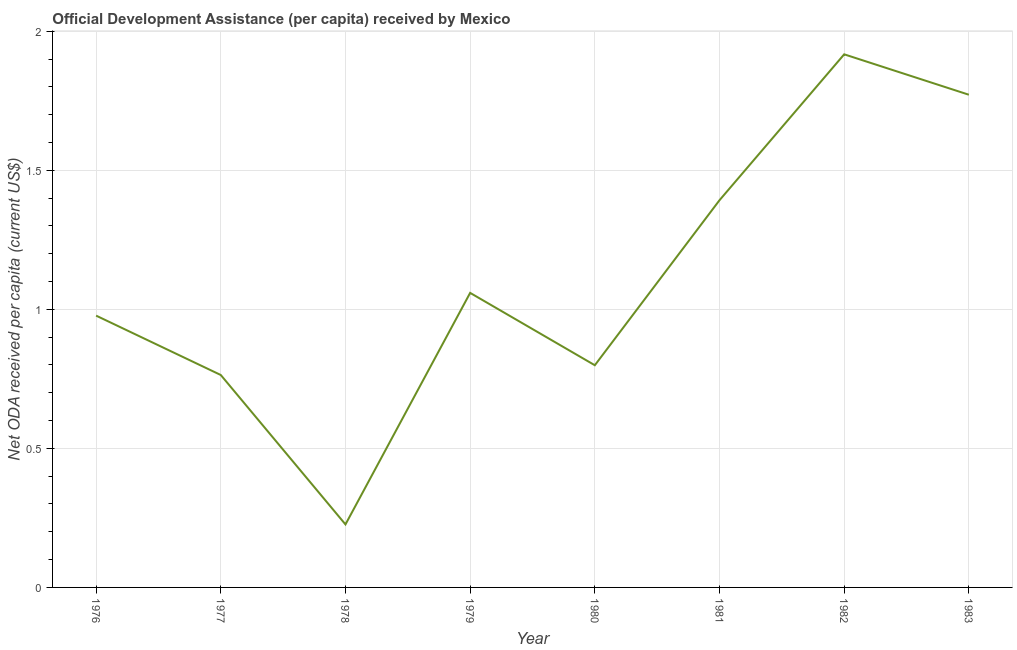What is the net oda received per capita in 1978?
Give a very brief answer. 0.23. Across all years, what is the maximum net oda received per capita?
Your response must be concise. 1.92. Across all years, what is the minimum net oda received per capita?
Your answer should be very brief. 0.23. In which year was the net oda received per capita minimum?
Offer a terse response. 1978. What is the sum of the net oda received per capita?
Provide a short and direct response. 8.91. What is the difference between the net oda received per capita in 1976 and 1979?
Provide a succinct answer. -0.08. What is the average net oda received per capita per year?
Your answer should be very brief. 1.11. What is the median net oda received per capita?
Offer a very short reply. 1.02. Do a majority of the years between 1982 and 1980 (inclusive) have net oda received per capita greater than 1.7 US$?
Give a very brief answer. No. What is the ratio of the net oda received per capita in 1977 to that in 1980?
Give a very brief answer. 0.96. Is the net oda received per capita in 1981 less than that in 1983?
Your response must be concise. Yes. Is the difference between the net oda received per capita in 1982 and 1983 greater than the difference between any two years?
Your answer should be very brief. No. What is the difference between the highest and the second highest net oda received per capita?
Make the answer very short. 0.15. Is the sum of the net oda received per capita in 1977 and 1982 greater than the maximum net oda received per capita across all years?
Provide a succinct answer. Yes. What is the difference between the highest and the lowest net oda received per capita?
Provide a succinct answer. 1.69. How many lines are there?
Keep it short and to the point. 1. What is the difference between two consecutive major ticks on the Y-axis?
Your answer should be compact. 0.5. Does the graph contain any zero values?
Your answer should be compact. No. What is the title of the graph?
Your response must be concise. Official Development Assistance (per capita) received by Mexico. What is the label or title of the X-axis?
Keep it short and to the point. Year. What is the label or title of the Y-axis?
Offer a very short reply. Net ODA received per capita (current US$). What is the Net ODA received per capita (current US$) of 1976?
Keep it short and to the point. 0.98. What is the Net ODA received per capita (current US$) in 1977?
Make the answer very short. 0.76. What is the Net ODA received per capita (current US$) in 1978?
Ensure brevity in your answer.  0.23. What is the Net ODA received per capita (current US$) in 1979?
Offer a terse response. 1.06. What is the Net ODA received per capita (current US$) in 1980?
Keep it short and to the point. 0.8. What is the Net ODA received per capita (current US$) in 1981?
Your answer should be very brief. 1.39. What is the Net ODA received per capita (current US$) in 1982?
Offer a very short reply. 1.92. What is the Net ODA received per capita (current US$) in 1983?
Your answer should be very brief. 1.77. What is the difference between the Net ODA received per capita (current US$) in 1976 and 1977?
Provide a short and direct response. 0.21. What is the difference between the Net ODA received per capita (current US$) in 1976 and 1978?
Make the answer very short. 0.75. What is the difference between the Net ODA received per capita (current US$) in 1976 and 1979?
Give a very brief answer. -0.08. What is the difference between the Net ODA received per capita (current US$) in 1976 and 1980?
Your answer should be compact. 0.18. What is the difference between the Net ODA received per capita (current US$) in 1976 and 1981?
Keep it short and to the point. -0.42. What is the difference between the Net ODA received per capita (current US$) in 1976 and 1982?
Your response must be concise. -0.94. What is the difference between the Net ODA received per capita (current US$) in 1976 and 1983?
Keep it short and to the point. -0.79. What is the difference between the Net ODA received per capita (current US$) in 1977 and 1978?
Make the answer very short. 0.54. What is the difference between the Net ODA received per capita (current US$) in 1977 and 1979?
Offer a very short reply. -0.3. What is the difference between the Net ODA received per capita (current US$) in 1977 and 1980?
Provide a short and direct response. -0.04. What is the difference between the Net ODA received per capita (current US$) in 1977 and 1981?
Your answer should be very brief. -0.63. What is the difference between the Net ODA received per capita (current US$) in 1977 and 1982?
Provide a short and direct response. -1.15. What is the difference between the Net ODA received per capita (current US$) in 1977 and 1983?
Keep it short and to the point. -1.01. What is the difference between the Net ODA received per capita (current US$) in 1978 and 1979?
Ensure brevity in your answer.  -0.83. What is the difference between the Net ODA received per capita (current US$) in 1978 and 1980?
Offer a very short reply. -0.57. What is the difference between the Net ODA received per capita (current US$) in 1978 and 1981?
Provide a succinct answer. -1.17. What is the difference between the Net ODA received per capita (current US$) in 1978 and 1982?
Provide a succinct answer. -1.69. What is the difference between the Net ODA received per capita (current US$) in 1978 and 1983?
Your answer should be very brief. -1.55. What is the difference between the Net ODA received per capita (current US$) in 1979 and 1980?
Your answer should be very brief. 0.26. What is the difference between the Net ODA received per capita (current US$) in 1979 and 1981?
Provide a short and direct response. -0.33. What is the difference between the Net ODA received per capita (current US$) in 1979 and 1982?
Provide a short and direct response. -0.86. What is the difference between the Net ODA received per capita (current US$) in 1979 and 1983?
Give a very brief answer. -0.71. What is the difference between the Net ODA received per capita (current US$) in 1980 and 1981?
Keep it short and to the point. -0.59. What is the difference between the Net ODA received per capita (current US$) in 1980 and 1982?
Keep it short and to the point. -1.12. What is the difference between the Net ODA received per capita (current US$) in 1980 and 1983?
Your response must be concise. -0.97. What is the difference between the Net ODA received per capita (current US$) in 1981 and 1982?
Offer a terse response. -0.52. What is the difference between the Net ODA received per capita (current US$) in 1981 and 1983?
Give a very brief answer. -0.38. What is the difference between the Net ODA received per capita (current US$) in 1982 and 1983?
Make the answer very short. 0.15. What is the ratio of the Net ODA received per capita (current US$) in 1976 to that in 1977?
Your response must be concise. 1.28. What is the ratio of the Net ODA received per capita (current US$) in 1976 to that in 1978?
Provide a succinct answer. 4.31. What is the ratio of the Net ODA received per capita (current US$) in 1976 to that in 1979?
Provide a succinct answer. 0.92. What is the ratio of the Net ODA received per capita (current US$) in 1976 to that in 1980?
Offer a terse response. 1.22. What is the ratio of the Net ODA received per capita (current US$) in 1976 to that in 1981?
Offer a terse response. 0.7. What is the ratio of the Net ODA received per capita (current US$) in 1976 to that in 1982?
Keep it short and to the point. 0.51. What is the ratio of the Net ODA received per capita (current US$) in 1976 to that in 1983?
Your response must be concise. 0.55. What is the ratio of the Net ODA received per capita (current US$) in 1977 to that in 1978?
Provide a short and direct response. 3.37. What is the ratio of the Net ODA received per capita (current US$) in 1977 to that in 1979?
Your response must be concise. 0.72. What is the ratio of the Net ODA received per capita (current US$) in 1977 to that in 1980?
Offer a very short reply. 0.96. What is the ratio of the Net ODA received per capita (current US$) in 1977 to that in 1981?
Ensure brevity in your answer.  0.55. What is the ratio of the Net ODA received per capita (current US$) in 1977 to that in 1982?
Make the answer very short. 0.4. What is the ratio of the Net ODA received per capita (current US$) in 1977 to that in 1983?
Your answer should be very brief. 0.43. What is the ratio of the Net ODA received per capita (current US$) in 1978 to that in 1979?
Your response must be concise. 0.21. What is the ratio of the Net ODA received per capita (current US$) in 1978 to that in 1980?
Offer a terse response. 0.28. What is the ratio of the Net ODA received per capita (current US$) in 1978 to that in 1981?
Offer a terse response. 0.16. What is the ratio of the Net ODA received per capita (current US$) in 1978 to that in 1982?
Give a very brief answer. 0.12. What is the ratio of the Net ODA received per capita (current US$) in 1978 to that in 1983?
Provide a succinct answer. 0.13. What is the ratio of the Net ODA received per capita (current US$) in 1979 to that in 1980?
Your answer should be compact. 1.33. What is the ratio of the Net ODA received per capita (current US$) in 1979 to that in 1981?
Ensure brevity in your answer.  0.76. What is the ratio of the Net ODA received per capita (current US$) in 1979 to that in 1982?
Give a very brief answer. 0.55. What is the ratio of the Net ODA received per capita (current US$) in 1979 to that in 1983?
Give a very brief answer. 0.6. What is the ratio of the Net ODA received per capita (current US$) in 1980 to that in 1981?
Offer a very short reply. 0.57. What is the ratio of the Net ODA received per capita (current US$) in 1980 to that in 1982?
Your answer should be compact. 0.42. What is the ratio of the Net ODA received per capita (current US$) in 1980 to that in 1983?
Your response must be concise. 0.45. What is the ratio of the Net ODA received per capita (current US$) in 1981 to that in 1982?
Make the answer very short. 0.73. What is the ratio of the Net ODA received per capita (current US$) in 1981 to that in 1983?
Your answer should be compact. 0.79. What is the ratio of the Net ODA received per capita (current US$) in 1982 to that in 1983?
Make the answer very short. 1.08. 